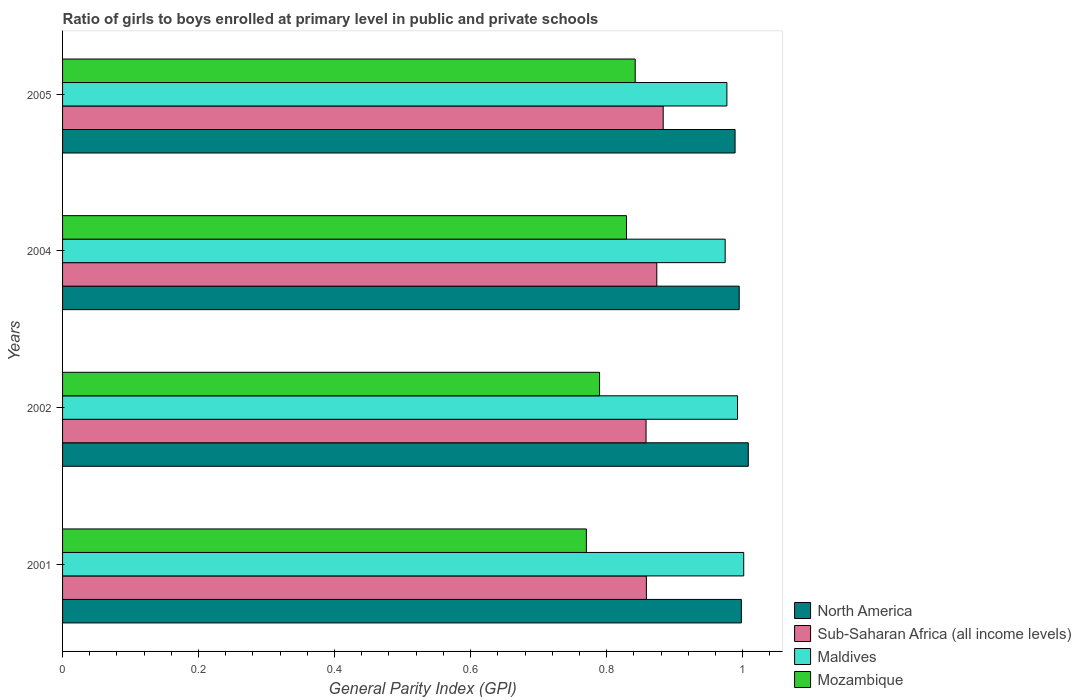How many different coloured bars are there?
Offer a terse response. 4. Are the number of bars on each tick of the Y-axis equal?
Your answer should be compact. Yes. How many bars are there on the 3rd tick from the top?
Offer a very short reply. 4. What is the label of the 2nd group of bars from the top?
Your answer should be very brief. 2004. What is the general parity index in Sub-Saharan Africa (all income levels) in 2002?
Ensure brevity in your answer.  0.86. Across all years, what is the maximum general parity index in Sub-Saharan Africa (all income levels)?
Provide a short and direct response. 0.88. Across all years, what is the minimum general parity index in North America?
Keep it short and to the point. 0.99. What is the total general parity index in North America in the graph?
Provide a succinct answer. 3.99. What is the difference between the general parity index in Mozambique in 2001 and that in 2005?
Provide a short and direct response. -0.07. What is the difference between the general parity index in Mozambique in 2004 and the general parity index in North America in 2002?
Provide a short and direct response. -0.18. What is the average general parity index in Sub-Saharan Africa (all income levels) per year?
Ensure brevity in your answer.  0.87. In the year 2002, what is the difference between the general parity index in Mozambique and general parity index in Maldives?
Ensure brevity in your answer.  -0.2. What is the ratio of the general parity index in Sub-Saharan Africa (all income levels) in 2002 to that in 2004?
Offer a terse response. 0.98. Is the general parity index in Sub-Saharan Africa (all income levels) in 2004 less than that in 2005?
Provide a short and direct response. Yes. What is the difference between the highest and the second highest general parity index in North America?
Make the answer very short. 0.01. What is the difference between the highest and the lowest general parity index in North America?
Make the answer very short. 0.02. In how many years, is the general parity index in Maldives greater than the average general parity index in Maldives taken over all years?
Your answer should be very brief. 2. Is it the case that in every year, the sum of the general parity index in Maldives and general parity index in Mozambique is greater than the sum of general parity index in Sub-Saharan Africa (all income levels) and general parity index in North America?
Ensure brevity in your answer.  No. What does the 1st bar from the top in 2005 represents?
Keep it short and to the point. Mozambique. What does the 2nd bar from the bottom in 2002 represents?
Ensure brevity in your answer.  Sub-Saharan Africa (all income levels). What is the difference between two consecutive major ticks on the X-axis?
Your answer should be compact. 0.2. Are the values on the major ticks of X-axis written in scientific E-notation?
Offer a very short reply. No. Does the graph contain grids?
Offer a very short reply. No. How many legend labels are there?
Your response must be concise. 4. What is the title of the graph?
Your response must be concise. Ratio of girls to boys enrolled at primary level in public and private schools. Does "Senegal" appear as one of the legend labels in the graph?
Ensure brevity in your answer.  No. What is the label or title of the X-axis?
Your response must be concise. General Parity Index (GPI). What is the label or title of the Y-axis?
Provide a short and direct response. Years. What is the General Parity Index (GPI) of North America in 2001?
Ensure brevity in your answer.  1. What is the General Parity Index (GPI) in Sub-Saharan Africa (all income levels) in 2001?
Your response must be concise. 0.86. What is the General Parity Index (GPI) of Maldives in 2001?
Keep it short and to the point. 1. What is the General Parity Index (GPI) in Mozambique in 2001?
Keep it short and to the point. 0.77. What is the General Parity Index (GPI) of North America in 2002?
Your response must be concise. 1.01. What is the General Parity Index (GPI) of Sub-Saharan Africa (all income levels) in 2002?
Offer a terse response. 0.86. What is the General Parity Index (GPI) of Maldives in 2002?
Offer a terse response. 0.99. What is the General Parity Index (GPI) of Mozambique in 2002?
Provide a short and direct response. 0.79. What is the General Parity Index (GPI) in North America in 2004?
Give a very brief answer. 1. What is the General Parity Index (GPI) of Sub-Saharan Africa (all income levels) in 2004?
Your answer should be compact. 0.87. What is the General Parity Index (GPI) in Maldives in 2004?
Your response must be concise. 0.97. What is the General Parity Index (GPI) in Mozambique in 2004?
Provide a short and direct response. 0.83. What is the General Parity Index (GPI) in North America in 2005?
Offer a terse response. 0.99. What is the General Parity Index (GPI) of Sub-Saharan Africa (all income levels) in 2005?
Give a very brief answer. 0.88. What is the General Parity Index (GPI) of Maldives in 2005?
Keep it short and to the point. 0.98. What is the General Parity Index (GPI) in Mozambique in 2005?
Provide a short and direct response. 0.84. Across all years, what is the maximum General Parity Index (GPI) in North America?
Your answer should be compact. 1.01. Across all years, what is the maximum General Parity Index (GPI) of Sub-Saharan Africa (all income levels)?
Ensure brevity in your answer.  0.88. Across all years, what is the maximum General Parity Index (GPI) in Maldives?
Provide a succinct answer. 1. Across all years, what is the maximum General Parity Index (GPI) in Mozambique?
Provide a short and direct response. 0.84. Across all years, what is the minimum General Parity Index (GPI) in North America?
Provide a short and direct response. 0.99. Across all years, what is the minimum General Parity Index (GPI) in Sub-Saharan Africa (all income levels)?
Your answer should be compact. 0.86. Across all years, what is the minimum General Parity Index (GPI) of Maldives?
Ensure brevity in your answer.  0.97. Across all years, what is the minimum General Parity Index (GPI) of Mozambique?
Your response must be concise. 0.77. What is the total General Parity Index (GPI) in North America in the graph?
Offer a terse response. 3.99. What is the total General Parity Index (GPI) in Sub-Saharan Africa (all income levels) in the graph?
Your answer should be very brief. 3.47. What is the total General Parity Index (GPI) in Maldives in the graph?
Make the answer very short. 3.95. What is the total General Parity Index (GPI) of Mozambique in the graph?
Ensure brevity in your answer.  3.23. What is the difference between the General Parity Index (GPI) of North America in 2001 and that in 2002?
Keep it short and to the point. -0.01. What is the difference between the General Parity Index (GPI) of Maldives in 2001 and that in 2002?
Provide a succinct answer. 0.01. What is the difference between the General Parity Index (GPI) of Mozambique in 2001 and that in 2002?
Provide a short and direct response. -0.02. What is the difference between the General Parity Index (GPI) of North America in 2001 and that in 2004?
Your answer should be very brief. 0. What is the difference between the General Parity Index (GPI) of Sub-Saharan Africa (all income levels) in 2001 and that in 2004?
Your answer should be very brief. -0.02. What is the difference between the General Parity Index (GPI) in Maldives in 2001 and that in 2004?
Your response must be concise. 0.03. What is the difference between the General Parity Index (GPI) in Mozambique in 2001 and that in 2004?
Your response must be concise. -0.06. What is the difference between the General Parity Index (GPI) in North America in 2001 and that in 2005?
Offer a very short reply. 0.01. What is the difference between the General Parity Index (GPI) in Sub-Saharan Africa (all income levels) in 2001 and that in 2005?
Your answer should be compact. -0.02. What is the difference between the General Parity Index (GPI) of Maldives in 2001 and that in 2005?
Give a very brief answer. 0.02. What is the difference between the General Parity Index (GPI) of Mozambique in 2001 and that in 2005?
Your answer should be very brief. -0.07. What is the difference between the General Parity Index (GPI) of North America in 2002 and that in 2004?
Provide a succinct answer. 0.01. What is the difference between the General Parity Index (GPI) in Sub-Saharan Africa (all income levels) in 2002 and that in 2004?
Give a very brief answer. -0.02. What is the difference between the General Parity Index (GPI) of Maldives in 2002 and that in 2004?
Your answer should be compact. 0.02. What is the difference between the General Parity Index (GPI) in Mozambique in 2002 and that in 2004?
Offer a very short reply. -0.04. What is the difference between the General Parity Index (GPI) in North America in 2002 and that in 2005?
Offer a very short reply. 0.02. What is the difference between the General Parity Index (GPI) of Sub-Saharan Africa (all income levels) in 2002 and that in 2005?
Your answer should be compact. -0.03. What is the difference between the General Parity Index (GPI) in Maldives in 2002 and that in 2005?
Ensure brevity in your answer.  0.02. What is the difference between the General Parity Index (GPI) in Mozambique in 2002 and that in 2005?
Keep it short and to the point. -0.05. What is the difference between the General Parity Index (GPI) in North America in 2004 and that in 2005?
Offer a terse response. 0.01. What is the difference between the General Parity Index (GPI) in Sub-Saharan Africa (all income levels) in 2004 and that in 2005?
Offer a terse response. -0.01. What is the difference between the General Parity Index (GPI) of Maldives in 2004 and that in 2005?
Your answer should be very brief. -0. What is the difference between the General Parity Index (GPI) in Mozambique in 2004 and that in 2005?
Your answer should be compact. -0.01. What is the difference between the General Parity Index (GPI) of North America in 2001 and the General Parity Index (GPI) of Sub-Saharan Africa (all income levels) in 2002?
Give a very brief answer. 0.14. What is the difference between the General Parity Index (GPI) of North America in 2001 and the General Parity Index (GPI) of Maldives in 2002?
Offer a terse response. 0.01. What is the difference between the General Parity Index (GPI) of North America in 2001 and the General Parity Index (GPI) of Mozambique in 2002?
Offer a terse response. 0.21. What is the difference between the General Parity Index (GPI) in Sub-Saharan Africa (all income levels) in 2001 and the General Parity Index (GPI) in Maldives in 2002?
Provide a short and direct response. -0.13. What is the difference between the General Parity Index (GPI) of Sub-Saharan Africa (all income levels) in 2001 and the General Parity Index (GPI) of Mozambique in 2002?
Make the answer very short. 0.07. What is the difference between the General Parity Index (GPI) of Maldives in 2001 and the General Parity Index (GPI) of Mozambique in 2002?
Your answer should be compact. 0.21. What is the difference between the General Parity Index (GPI) of North America in 2001 and the General Parity Index (GPI) of Sub-Saharan Africa (all income levels) in 2004?
Provide a short and direct response. 0.12. What is the difference between the General Parity Index (GPI) in North America in 2001 and the General Parity Index (GPI) in Maldives in 2004?
Your response must be concise. 0.02. What is the difference between the General Parity Index (GPI) in North America in 2001 and the General Parity Index (GPI) in Mozambique in 2004?
Make the answer very short. 0.17. What is the difference between the General Parity Index (GPI) in Sub-Saharan Africa (all income levels) in 2001 and the General Parity Index (GPI) in Maldives in 2004?
Give a very brief answer. -0.12. What is the difference between the General Parity Index (GPI) of Sub-Saharan Africa (all income levels) in 2001 and the General Parity Index (GPI) of Mozambique in 2004?
Your answer should be compact. 0.03. What is the difference between the General Parity Index (GPI) in Maldives in 2001 and the General Parity Index (GPI) in Mozambique in 2004?
Keep it short and to the point. 0.17. What is the difference between the General Parity Index (GPI) of North America in 2001 and the General Parity Index (GPI) of Sub-Saharan Africa (all income levels) in 2005?
Your answer should be very brief. 0.12. What is the difference between the General Parity Index (GPI) in North America in 2001 and the General Parity Index (GPI) in Maldives in 2005?
Your answer should be compact. 0.02. What is the difference between the General Parity Index (GPI) of North America in 2001 and the General Parity Index (GPI) of Mozambique in 2005?
Offer a terse response. 0.16. What is the difference between the General Parity Index (GPI) of Sub-Saharan Africa (all income levels) in 2001 and the General Parity Index (GPI) of Maldives in 2005?
Offer a terse response. -0.12. What is the difference between the General Parity Index (GPI) of Sub-Saharan Africa (all income levels) in 2001 and the General Parity Index (GPI) of Mozambique in 2005?
Offer a terse response. 0.02. What is the difference between the General Parity Index (GPI) of Maldives in 2001 and the General Parity Index (GPI) of Mozambique in 2005?
Provide a short and direct response. 0.16. What is the difference between the General Parity Index (GPI) in North America in 2002 and the General Parity Index (GPI) in Sub-Saharan Africa (all income levels) in 2004?
Make the answer very short. 0.13. What is the difference between the General Parity Index (GPI) of North America in 2002 and the General Parity Index (GPI) of Maldives in 2004?
Ensure brevity in your answer.  0.03. What is the difference between the General Parity Index (GPI) of North America in 2002 and the General Parity Index (GPI) of Mozambique in 2004?
Your answer should be compact. 0.18. What is the difference between the General Parity Index (GPI) in Sub-Saharan Africa (all income levels) in 2002 and the General Parity Index (GPI) in Maldives in 2004?
Your response must be concise. -0.12. What is the difference between the General Parity Index (GPI) of Sub-Saharan Africa (all income levels) in 2002 and the General Parity Index (GPI) of Mozambique in 2004?
Give a very brief answer. 0.03. What is the difference between the General Parity Index (GPI) in Maldives in 2002 and the General Parity Index (GPI) in Mozambique in 2004?
Ensure brevity in your answer.  0.16. What is the difference between the General Parity Index (GPI) in North America in 2002 and the General Parity Index (GPI) in Sub-Saharan Africa (all income levels) in 2005?
Make the answer very short. 0.13. What is the difference between the General Parity Index (GPI) of North America in 2002 and the General Parity Index (GPI) of Maldives in 2005?
Keep it short and to the point. 0.03. What is the difference between the General Parity Index (GPI) in North America in 2002 and the General Parity Index (GPI) in Mozambique in 2005?
Provide a succinct answer. 0.17. What is the difference between the General Parity Index (GPI) in Sub-Saharan Africa (all income levels) in 2002 and the General Parity Index (GPI) in Maldives in 2005?
Provide a succinct answer. -0.12. What is the difference between the General Parity Index (GPI) of Sub-Saharan Africa (all income levels) in 2002 and the General Parity Index (GPI) of Mozambique in 2005?
Offer a very short reply. 0.02. What is the difference between the General Parity Index (GPI) in Maldives in 2002 and the General Parity Index (GPI) in Mozambique in 2005?
Offer a terse response. 0.15. What is the difference between the General Parity Index (GPI) in North America in 2004 and the General Parity Index (GPI) in Sub-Saharan Africa (all income levels) in 2005?
Make the answer very short. 0.11. What is the difference between the General Parity Index (GPI) of North America in 2004 and the General Parity Index (GPI) of Maldives in 2005?
Keep it short and to the point. 0.02. What is the difference between the General Parity Index (GPI) of North America in 2004 and the General Parity Index (GPI) of Mozambique in 2005?
Provide a short and direct response. 0.15. What is the difference between the General Parity Index (GPI) in Sub-Saharan Africa (all income levels) in 2004 and the General Parity Index (GPI) in Maldives in 2005?
Provide a short and direct response. -0.1. What is the difference between the General Parity Index (GPI) of Sub-Saharan Africa (all income levels) in 2004 and the General Parity Index (GPI) of Mozambique in 2005?
Your response must be concise. 0.03. What is the difference between the General Parity Index (GPI) of Maldives in 2004 and the General Parity Index (GPI) of Mozambique in 2005?
Your response must be concise. 0.13. What is the average General Parity Index (GPI) of North America per year?
Give a very brief answer. 1. What is the average General Parity Index (GPI) of Sub-Saharan Africa (all income levels) per year?
Your answer should be compact. 0.87. What is the average General Parity Index (GPI) in Maldives per year?
Ensure brevity in your answer.  0.99. What is the average General Parity Index (GPI) of Mozambique per year?
Give a very brief answer. 0.81. In the year 2001, what is the difference between the General Parity Index (GPI) in North America and General Parity Index (GPI) in Sub-Saharan Africa (all income levels)?
Give a very brief answer. 0.14. In the year 2001, what is the difference between the General Parity Index (GPI) in North America and General Parity Index (GPI) in Maldives?
Your answer should be very brief. -0. In the year 2001, what is the difference between the General Parity Index (GPI) in North America and General Parity Index (GPI) in Mozambique?
Provide a short and direct response. 0.23. In the year 2001, what is the difference between the General Parity Index (GPI) in Sub-Saharan Africa (all income levels) and General Parity Index (GPI) in Maldives?
Provide a succinct answer. -0.14. In the year 2001, what is the difference between the General Parity Index (GPI) of Sub-Saharan Africa (all income levels) and General Parity Index (GPI) of Mozambique?
Keep it short and to the point. 0.09. In the year 2001, what is the difference between the General Parity Index (GPI) in Maldives and General Parity Index (GPI) in Mozambique?
Your answer should be very brief. 0.23. In the year 2002, what is the difference between the General Parity Index (GPI) of North America and General Parity Index (GPI) of Sub-Saharan Africa (all income levels)?
Keep it short and to the point. 0.15. In the year 2002, what is the difference between the General Parity Index (GPI) in North America and General Parity Index (GPI) in Maldives?
Make the answer very short. 0.02. In the year 2002, what is the difference between the General Parity Index (GPI) of North America and General Parity Index (GPI) of Mozambique?
Offer a terse response. 0.22. In the year 2002, what is the difference between the General Parity Index (GPI) of Sub-Saharan Africa (all income levels) and General Parity Index (GPI) of Maldives?
Offer a terse response. -0.13. In the year 2002, what is the difference between the General Parity Index (GPI) of Sub-Saharan Africa (all income levels) and General Parity Index (GPI) of Mozambique?
Ensure brevity in your answer.  0.07. In the year 2002, what is the difference between the General Parity Index (GPI) in Maldives and General Parity Index (GPI) in Mozambique?
Your answer should be compact. 0.2. In the year 2004, what is the difference between the General Parity Index (GPI) in North America and General Parity Index (GPI) in Sub-Saharan Africa (all income levels)?
Ensure brevity in your answer.  0.12. In the year 2004, what is the difference between the General Parity Index (GPI) in North America and General Parity Index (GPI) in Maldives?
Keep it short and to the point. 0.02. In the year 2004, what is the difference between the General Parity Index (GPI) in North America and General Parity Index (GPI) in Mozambique?
Your response must be concise. 0.17. In the year 2004, what is the difference between the General Parity Index (GPI) in Sub-Saharan Africa (all income levels) and General Parity Index (GPI) in Maldives?
Provide a short and direct response. -0.1. In the year 2004, what is the difference between the General Parity Index (GPI) in Sub-Saharan Africa (all income levels) and General Parity Index (GPI) in Mozambique?
Give a very brief answer. 0.04. In the year 2004, what is the difference between the General Parity Index (GPI) in Maldives and General Parity Index (GPI) in Mozambique?
Your answer should be compact. 0.15. In the year 2005, what is the difference between the General Parity Index (GPI) in North America and General Parity Index (GPI) in Sub-Saharan Africa (all income levels)?
Your response must be concise. 0.11. In the year 2005, what is the difference between the General Parity Index (GPI) of North America and General Parity Index (GPI) of Maldives?
Keep it short and to the point. 0.01. In the year 2005, what is the difference between the General Parity Index (GPI) of North America and General Parity Index (GPI) of Mozambique?
Your answer should be compact. 0.15. In the year 2005, what is the difference between the General Parity Index (GPI) of Sub-Saharan Africa (all income levels) and General Parity Index (GPI) of Maldives?
Provide a succinct answer. -0.09. In the year 2005, what is the difference between the General Parity Index (GPI) in Sub-Saharan Africa (all income levels) and General Parity Index (GPI) in Mozambique?
Keep it short and to the point. 0.04. In the year 2005, what is the difference between the General Parity Index (GPI) in Maldives and General Parity Index (GPI) in Mozambique?
Provide a short and direct response. 0.13. What is the ratio of the General Parity Index (GPI) of Maldives in 2001 to that in 2002?
Keep it short and to the point. 1.01. What is the ratio of the General Parity Index (GPI) of Mozambique in 2001 to that in 2002?
Offer a terse response. 0.98. What is the ratio of the General Parity Index (GPI) in Sub-Saharan Africa (all income levels) in 2001 to that in 2004?
Your answer should be compact. 0.98. What is the ratio of the General Parity Index (GPI) of Maldives in 2001 to that in 2004?
Your answer should be very brief. 1.03. What is the ratio of the General Parity Index (GPI) of Mozambique in 2001 to that in 2004?
Keep it short and to the point. 0.93. What is the ratio of the General Parity Index (GPI) in North America in 2001 to that in 2005?
Provide a succinct answer. 1.01. What is the ratio of the General Parity Index (GPI) in Sub-Saharan Africa (all income levels) in 2001 to that in 2005?
Your response must be concise. 0.97. What is the ratio of the General Parity Index (GPI) of Maldives in 2001 to that in 2005?
Keep it short and to the point. 1.03. What is the ratio of the General Parity Index (GPI) of Mozambique in 2001 to that in 2005?
Provide a succinct answer. 0.91. What is the ratio of the General Parity Index (GPI) in North America in 2002 to that in 2004?
Your answer should be compact. 1.01. What is the ratio of the General Parity Index (GPI) in Sub-Saharan Africa (all income levels) in 2002 to that in 2004?
Offer a terse response. 0.98. What is the ratio of the General Parity Index (GPI) in Maldives in 2002 to that in 2004?
Offer a terse response. 1.02. What is the ratio of the General Parity Index (GPI) of Mozambique in 2002 to that in 2004?
Your answer should be very brief. 0.95. What is the ratio of the General Parity Index (GPI) in North America in 2002 to that in 2005?
Keep it short and to the point. 1.02. What is the ratio of the General Parity Index (GPI) in Sub-Saharan Africa (all income levels) in 2002 to that in 2005?
Make the answer very short. 0.97. What is the ratio of the General Parity Index (GPI) of Mozambique in 2002 to that in 2005?
Your answer should be compact. 0.94. What is the ratio of the General Parity Index (GPI) of North America in 2004 to that in 2005?
Your answer should be very brief. 1.01. What is the ratio of the General Parity Index (GPI) in Sub-Saharan Africa (all income levels) in 2004 to that in 2005?
Give a very brief answer. 0.99. What is the ratio of the General Parity Index (GPI) of Maldives in 2004 to that in 2005?
Provide a short and direct response. 1. What is the ratio of the General Parity Index (GPI) in Mozambique in 2004 to that in 2005?
Offer a very short reply. 0.98. What is the difference between the highest and the second highest General Parity Index (GPI) in North America?
Give a very brief answer. 0.01. What is the difference between the highest and the second highest General Parity Index (GPI) of Sub-Saharan Africa (all income levels)?
Offer a very short reply. 0.01. What is the difference between the highest and the second highest General Parity Index (GPI) of Maldives?
Offer a terse response. 0.01. What is the difference between the highest and the second highest General Parity Index (GPI) in Mozambique?
Offer a terse response. 0.01. What is the difference between the highest and the lowest General Parity Index (GPI) of North America?
Make the answer very short. 0.02. What is the difference between the highest and the lowest General Parity Index (GPI) in Sub-Saharan Africa (all income levels)?
Give a very brief answer. 0.03. What is the difference between the highest and the lowest General Parity Index (GPI) in Maldives?
Make the answer very short. 0.03. What is the difference between the highest and the lowest General Parity Index (GPI) of Mozambique?
Provide a short and direct response. 0.07. 